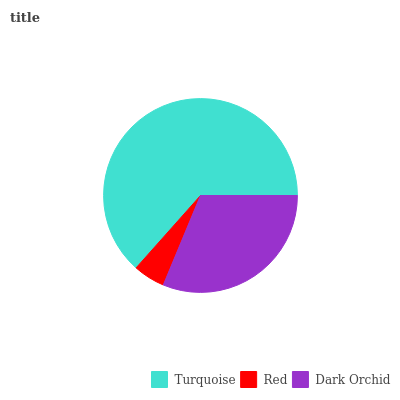Is Red the minimum?
Answer yes or no. Yes. Is Turquoise the maximum?
Answer yes or no. Yes. Is Dark Orchid the minimum?
Answer yes or no. No. Is Dark Orchid the maximum?
Answer yes or no. No. Is Dark Orchid greater than Red?
Answer yes or no. Yes. Is Red less than Dark Orchid?
Answer yes or no. Yes. Is Red greater than Dark Orchid?
Answer yes or no. No. Is Dark Orchid less than Red?
Answer yes or no. No. Is Dark Orchid the high median?
Answer yes or no. Yes. Is Dark Orchid the low median?
Answer yes or no. Yes. Is Turquoise the high median?
Answer yes or no. No. Is Turquoise the low median?
Answer yes or no. No. 